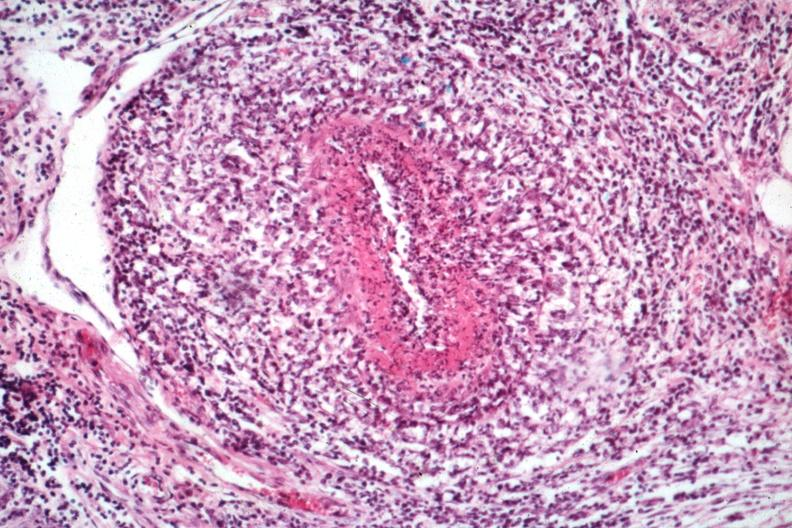does this image show classical polyarteritis nodosa type lesion?
Answer the question using a single word or phrase. Yes 